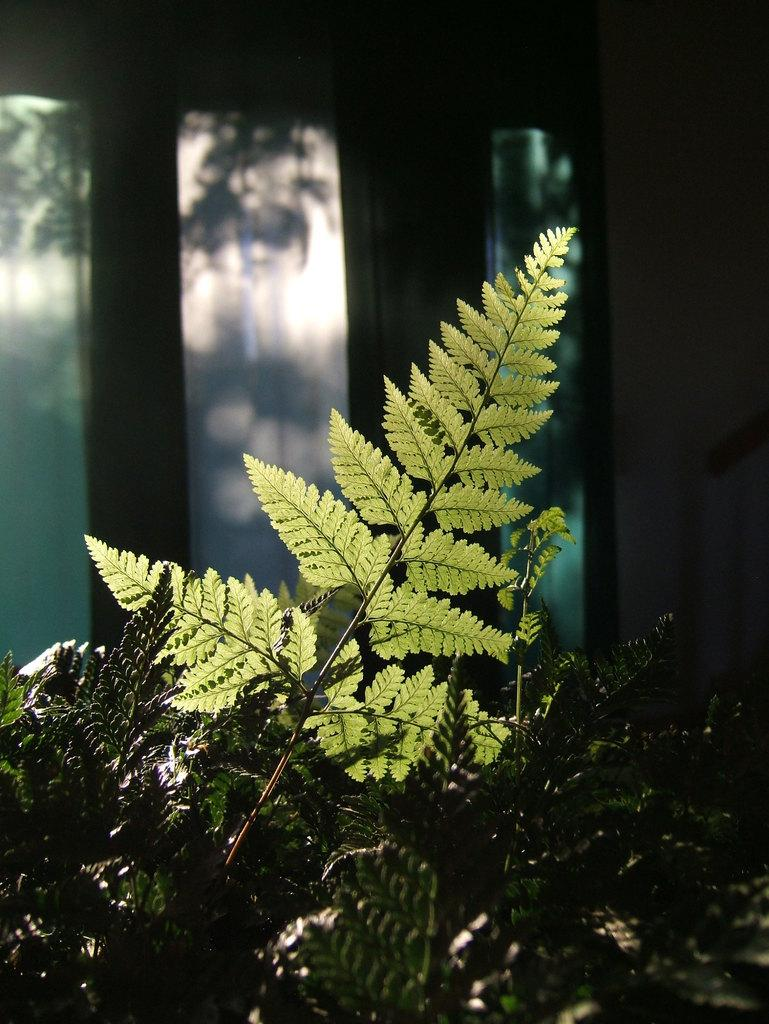What is located at the bottom of the image? There are plants at the bottom of the image. What can be seen in the background of the image? There is a window and trees visible in the background of the image. Where was the image taken? The image was taken in a room. What songs are being sung by the plants in the image? There are no songs being sung by the plants in the image, as plants do not have the ability to sing. Who is the owner of the plants in the image? There is no information about the owner of the plants in the image. 